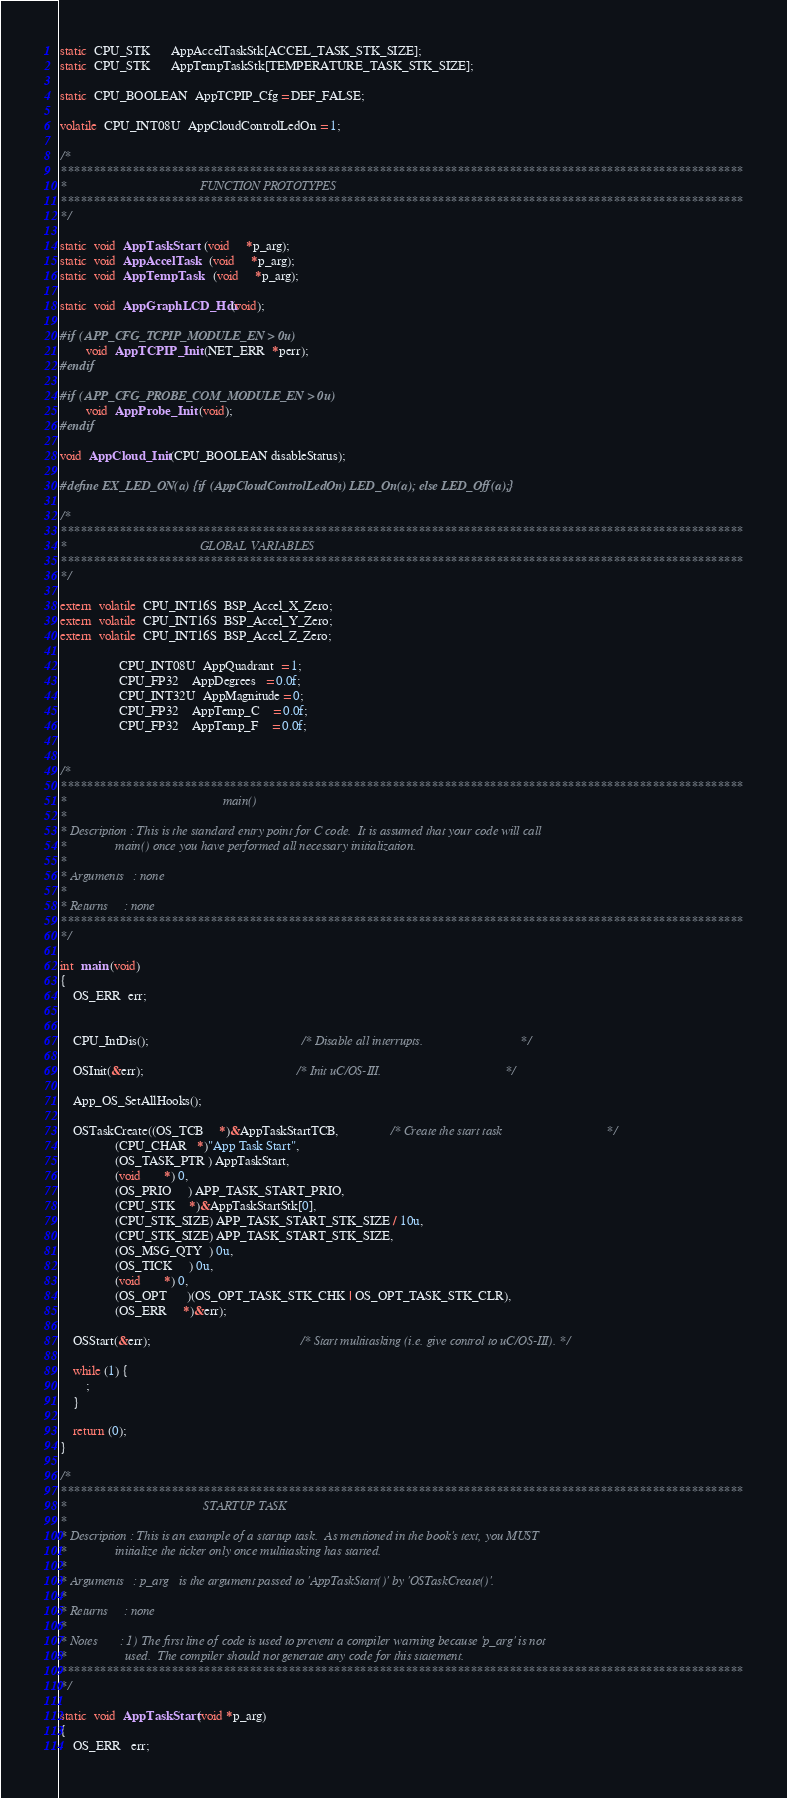<code> <loc_0><loc_0><loc_500><loc_500><_C_>static  CPU_STK      AppAccelTaskStk[ACCEL_TASK_STK_SIZE];
static  CPU_STK      AppTempTaskStk[TEMPERATURE_TASK_STK_SIZE];

static  CPU_BOOLEAN  AppTCPIP_Cfg = DEF_FALSE;

volatile  CPU_INT08U  AppCloudControlLedOn = 1;

/*
*********************************************************************************************************
*                                         FUNCTION PROTOTYPES
*********************************************************************************************************
*/

static  void  AppTaskStart   (void     *p_arg);
static  void  AppAccelTask   (void     *p_arg);
static  void  AppTempTask    (void     *p_arg);

static  void  AppGraphLCD_Hdr(void);

#if (APP_CFG_TCPIP_MODULE_EN > 0u)
        void  AppTCPIP_Init  (NET_ERR  *perr);
#endif

#if (APP_CFG_PROBE_COM_MODULE_EN > 0u)
        void  AppProbe_Init  (void);
#endif

void  AppCloud_Init (CPU_BOOLEAN disableStatus);

#define EX_LED_ON(a) {if (AppCloudControlLedOn) LED_On(a); else LED_Off(a);}

/*
*********************************************************************************************************
*                                         GLOBAL VARIABLES
*********************************************************************************************************
*/

extern  volatile  CPU_INT16S  BSP_Accel_X_Zero;
extern  volatile  CPU_INT16S  BSP_Accel_Y_Zero;
extern  volatile  CPU_INT16S  BSP_Accel_Z_Zero;

                  CPU_INT08U  AppQuadrant  = 1;
                  CPU_FP32    AppDegrees   = 0.0f;
                  CPU_INT32U  AppMagnitude = 0;
                  CPU_FP32    AppTemp_C    = 0.0f;
                  CPU_FP32    AppTemp_F    = 0.0f;


/*
*********************************************************************************************************
*                                                main()
*
* Description : This is the standard entry point for C code.  It is assumed that your code will call
*               main() once you have performed all necessary initialization.
*
* Arguments   : none
*
* Returns     : none
*********************************************************************************************************
*/

int  main (void)
{
    OS_ERR  err;


    CPU_IntDis();                                               /* Disable all interrupts.                              */

    OSInit(&err);                                               /* Init uC/OS-III.                                      */

    App_OS_SetAllHooks();

    OSTaskCreate((OS_TCB     *)&AppTaskStartTCB,                /* Create the start task                                */
                 (CPU_CHAR   *)"App Task Start",
                 (OS_TASK_PTR ) AppTaskStart,
                 (void       *) 0,
                 (OS_PRIO     ) APP_TASK_START_PRIO,
                 (CPU_STK    *)&AppTaskStartStk[0],
                 (CPU_STK_SIZE) APP_TASK_START_STK_SIZE / 10u,
                 (CPU_STK_SIZE) APP_TASK_START_STK_SIZE,
                 (OS_MSG_QTY  ) 0u,
                 (OS_TICK     ) 0u,
                 (void       *) 0,
                 (OS_OPT      )(OS_OPT_TASK_STK_CHK | OS_OPT_TASK_STK_CLR),
                 (OS_ERR     *)&err);

    OSStart(&err);                                              /* Start multitasking (i.e. give control to uC/OS-III). */

    while (1) {
        ;
    }

    return (0);
}

/*
*********************************************************************************************************
*                                          STARTUP TASK
*
* Description : This is an example of a startup task.  As mentioned in the book's text, you MUST
*               initialize the ticker only once multitasking has started.
*
* Arguments   : p_arg   is the argument passed to 'AppTaskStart()' by 'OSTaskCreate()'.
*
* Returns     : none
*
* Notes       : 1) The first line of code is used to prevent a compiler warning because 'p_arg' is not
*                  used.  The compiler should not generate any code for this statement.
*********************************************************************************************************
*/

static  void  AppTaskStart (void *p_arg)
{
    OS_ERR   err;</code> 